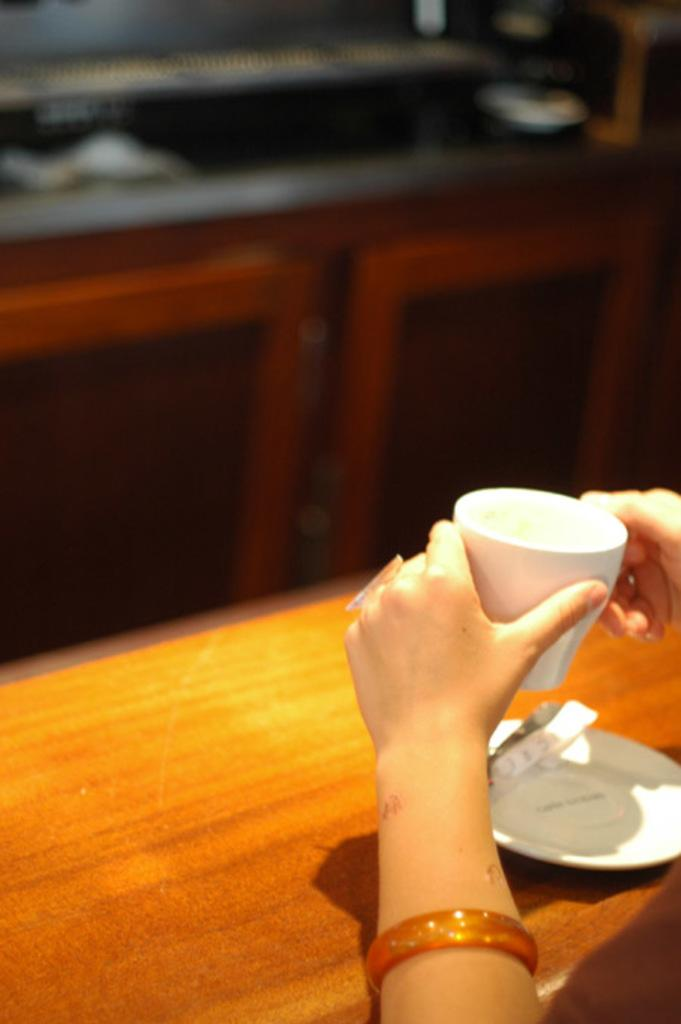What is being held by the human hands in the image? A tea cup is being held by the human hands in the image. What type of jewelry can be seen on the hand holding the tea cup? A bangle and a finger ring are visible on the hand holding the tea cup. What accompanies the tea cup in the image? There is a saucer in the image. What type of surface is the tea cup and saucer placed on? The tea cup and saucer are placed on a wooden surface in the image. How would you describe the background of the image? The background of the image is blurred. What type of shade is being cast by the nose in the image? There is no nose present in the image, so it is not possible to determine if any shade is being cast. 